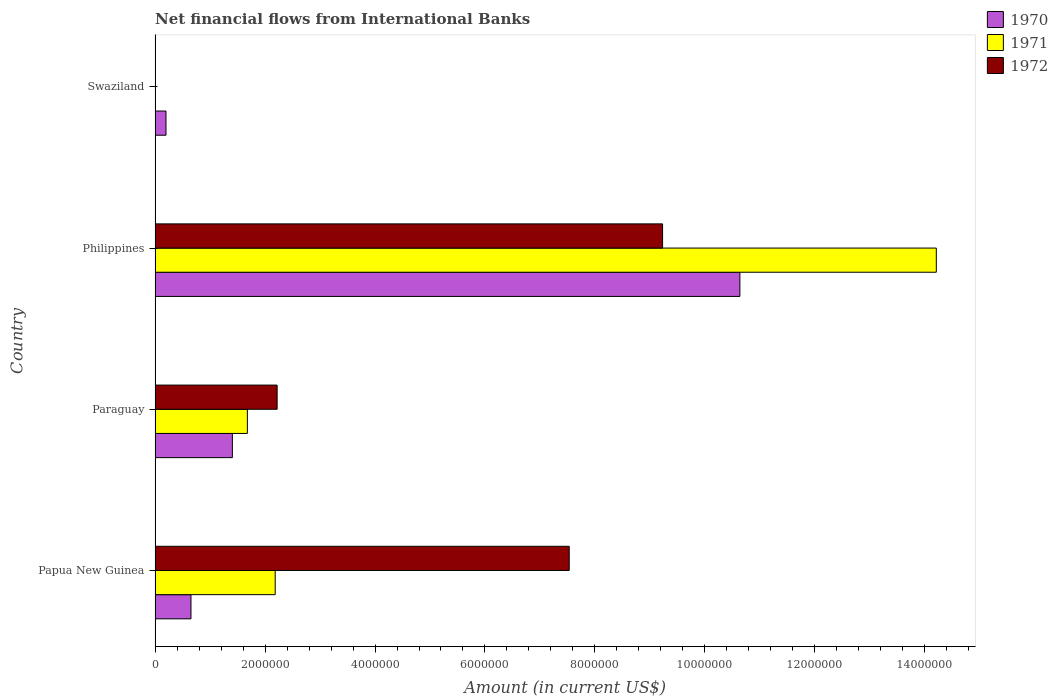How many different coloured bars are there?
Give a very brief answer. 3. Are the number of bars per tick equal to the number of legend labels?
Your response must be concise. No. Are the number of bars on each tick of the Y-axis equal?
Provide a succinct answer. No. How many bars are there on the 4th tick from the bottom?
Your answer should be compact. 1. What is the label of the 3rd group of bars from the top?
Ensure brevity in your answer.  Paraguay. In how many cases, is the number of bars for a given country not equal to the number of legend labels?
Your response must be concise. 1. What is the net financial aid flows in 1972 in Philippines?
Give a very brief answer. 9.23e+06. Across all countries, what is the maximum net financial aid flows in 1972?
Offer a terse response. 9.23e+06. Across all countries, what is the minimum net financial aid flows in 1972?
Provide a short and direct response. 0. In which country was the net financial aid flows in 1971 maximum?
Your answer should be compact. Philippines. What is the total net financial aid flows in 1971 in the graph?
Your response must be concise. 1.81e+07. What is the difference between the net financial aid flows in 1970 in Papua New Guinea and that in Paraguay?
Your answer should be very brief. -7.53e+05. What is the difference between the net financial aid flows in 1972 in Papua New Guinea and the net financial aid flows in 1970 in Swaziland?
Your answer should be compact. 7.33e+06. What is the average net financial aid flows in 1970 per country?
Your answer should be very brief. 3.22e+06. What is the difference between the net financial aid flows in 1972 and net financial aid flows in 1971 in Philippines?
Provide a short and direct response. -4.98e+06. In how many countries, is the net financial aid flows in 1972 greater than 5600000 US$?
Provide a short and direct response. 2. What is the ratio of the net financial aid flows in 1972 in Papua New Guinea to that in Philippines?
Ensure brevity in your answer.  0.82. What is the difference between the highest and the second highest net financial aid flows in 1972?
Offer a very short reply. 1.70e+06. What is the difference between the highest and the lowest net financial aid flows in 1972?
Provide a short and direct response. 9.23e+06. In how many countries, is the net financial aid flows in 1970 greater than the average net financial aid flows in 1970 taken over all countries?
Give a very brief answer. 1. Is it the case that in every country, the sum of the net financial aid flows in 1972 and net financial aid flows in 1970 is greater than the net financial aid flows in 1971?
Ensure brevity in your answer.  Yes. How many bars are there?
Keep it short and to the point. 10. Are the values on the major ticks of X-axis written in scientific E-notation?
Ensure brevity in your answer.  No. Does the graph contain grids?
Provide a short and direct response. No. How are the legend labels stacked?
Provide a short and direct response. Vertical. What is the title of the graph?
Give a very brief answer. Net financial flows from International Banks. What is the label or title of the Y-axis?
Make the answer very short. Country. What is the Amount (in current US$) of 1970 in Papua New Guinea?
Your response must be concise. 6.53e+05. What is the Amount (in current US$) of 1971 in Papua New Guinea?
Your answer should be compact. 2.18e+06. What is the Amount (in current US$) in 1972 in Papua New Guinea?
Provide a short and direct response. 7.53e+06. What is the Amount (in current US$) in 1970 in Paraguay?
Your answer should be compact. 1.41e+06. What is the Amount (in current US$) of 1971 in Paraguay?
Provide a short and direct response. 1.68e+06. What is the Amount (in current US$) of 1972 in Paraguay?
Give a very brief answer. 2.22e+06. What is the Amount (in current US$) of 1970 in Philippines?
Give a very brief answer. 1.06e+07. What is the Amount (in current US$) in 1971 in Philippines?
Offer a very short reply. 1.42e+07. What is the Amount (in current US$) of 1972 in Philippines?
Offer a very short reply. 9.23e+06. What is the Amount (in current US$) of 1970 in Swaziland?
Your answer should be compact. 1.99e+05. Across all countries, what is the maximum Amount (in current US$) of 1970?
Offer a terse response. 1.06e+07. Across all countries, what is the maximum Amount (in current US$) of 1971?
Offer a very short reply. 1.42e+07. Across all countries, what is the maximum Amount (in current US$) of 1972?
Ensure brevity in your answer.  9.23e+06. Across all countries, what is the minimum Amount (in current US$) of 1970?
Ensure brevity in your answer.  1.99e+05. Across all countries, what is the minimum Amount (in current US$) in 1971?
Keep it short and to the point. 0. What is the total Amount (in current US$) of 1970 in the graph?
Your response must be concise. 1.29e+07. What is the total Amount (in current US$) in 1971 in the graph?
Your answer should be very brief. 1.81e+07. What is the total Amount (in current US$) in 1972 in the graph?
Your response must be concise. 1.90e+07. What is the difference between the Amount (in current US$) of 1970 in Papua New Guinea and that in Paraguay?
Offer a very short reply. -7.53e+05. What is the difference between the Amount (in current US$) in 1971 in Papua New Guinea and that in Paraguay?
Your answer should be compact. 5.06e+05. What is the difference between the Amount (in current US$) of 1972 in Papua New Guinea and that in Paraguay?
Give a very brief answer. 5.31e+06. What is the difference between the Amount (in current US$) of 1970 in Papua New Guinea and that in Philippines?
Offer a very short reply. -9.98e+06. What is the difference between the Amount (in current US$) of 1971 in Papua New Guinea and that in Philippines?
Your answer should be compact. -1.20e+07. What is the difference between the Amount (in current US$) in 1972 in Papua New Guinea and that in Philippines?
Ensure brevity in your answer.  -1.70e+06. What is the difference between the Amount (in current US$) of 1970 in Papua New Guinea and that in Swaziland?
Provide a succinct answer. 4.54e+05. What is the difference between the Amount (in current US$) in 1970 in Paraguay and that in Philippines?
Your response must be concise. -9.23e+06. What is the difference between the Amount (in current US$) of 1971 in Paraguay and that in Philippines?
Provide a succinct answer. -1.25e+07. What is the difference between the Amount (in current US$) of 1972 in Paraguay and that in Philippines?
Your answer should be compact. -7.01e+06. What is the difference between the Amount (in current US$) in 1970 in Paraguay and that in Swaziland?
Ensure brevity in your answer.  1.21e+06. What is the difference between the Amount (in current US$) in 1970 in Philippines and that in Swaziland?
Provide a short and direct response. 1.04e+07. What is the difference between the Amount (in current US$) in 1970 in Papua New Guinea and the Amount (in current US$) in 1971 in Paraguay?
Your answer should be very brief. -1.03e+06. What is the difference between the Amount (in current US$) of 1970 in Papua New Guinea and the Amount (in current US$) of 1972 in Paraguay?
Offer a terse response. -1.57e+06. What is the difference between the Amount (in current US$) of 1971 in Papua New Guinea and the Amount (in current US$) of 1972 in Paraguay?
Your answer should be very brief. -3.50e+04. What is the difference between the Amount (in current US$) in 1970 in Papua New Guinea and the Amount (in current US$) in 1971 in Philippines?
Your answer should be very brief. -1.36e+07. What is the difference between the Amount (in current US$) in 1970 in Papua New Guinea and the Amount (in current US$) in 1972 in Philippines?
Your response must be concise. -8.58e+06. What is the difference between the Amount (in current US$) in 1971 in Papua New Guinea and the Amount (in current US$) in 1972 in Philippines?
Ensure brevity in your answer.  -7.04e+06. What is the difference between the Amount (in current US$) in 1970 in Paraguay and the Amount (in current US$) in 1971 in Philippines?
Your response must be concise. -1.28e+07. What is the difference between the Amount (in current US$) of 1970 in Paraguay and the Amount (in current US$) of 1972 in Philippines?
Your response must be concise. -7.82e+06. What is the difference between the Amount (in current US$) in 1971 in Paraguay and the Amount (in current US$) in 1972 in Philippines?
Ensure brevity in your answer.  -7.55e+06. What is the average Amount (in current US$) of 1970 per country?
Provide a succinct answer. 3.22e+06. What is the average Amount (in current US$) of 1971 per country?
Your answer should be compact. 4.52e+06. What is the average Amount (in current US$) in 1972 per country?
Your response must be concise. 4.75e+06. What is the difference between the Amount (in current US$) in 1970 and Amount (in current US$) in 1971 in Papua New Guinea?
Offer a very short reply. -1.53e+06. What is the difference between the Amount (in current US$) in 1970 and Amount (in current US$) in 1972 in Papua New Guinea?
Give a very brief answer. -6.88e+06. What is the difference between the Amount (in current US$) in 1971 and Amount (in current US$) in 1972 in Papua New Guinea?
Ensure brevity in your answer.  -5.35e+06. What is the difference between the Amount (in current US$) of 1970 and Amount (in current US$) of 1971 in Paraguay?
Provide a succinct answer. -2.73e+05. What is the difference between the Amount (in current US$) in 1970 and Amount (in current US$) in 1972 in Paraguay?
Give a very brief answer. -8.14e+05. What is the difference between the Amount (in current US$) in 1971 and Amount (in current US$) in 1972 in Paraguay?
Provide a succinct answer. -5.41e+05. What is the difference between the Amount (in current US$) in 1970 and Amount (in current US$) in 1971 in Philippines?
Provide a succinct answer. -3.57e+06. What is the difference between the Amount (in current US$) of 1970 and Amount (in current US$) of 1972 in Philippines?
Ensure brevity in your answer.  1.41e+06. What is the difference between the Amount (in current US$) in 1971 and Amount (in current US$) in 1972 in Philippines?
Your answer should be compact. 4.98e+06. What is the ratio of the Amount (in current US$) in 1970 in Papua New Guinea to that in Paraguay?
Your response must be concise. 0.46. What is the ratio of the Amount (in current US$) in 1971 in Papua New Guinea to that in Paraguay?
Make the answer very short. 1.3. What is the ratio of the Amount (in current US$) of 1972 in Papua New Guinea to that in Paraguay?
Make the answer very short. 3.39. What is the ratio of the Amount (in current US$) of 1970 in Papua New Guinea to that in Philippines?
Offer a terse response. 0.06. What is the ratio of the Amount (in current US$) in 1971 in Papua New Guinea to that in Philippines?
Offer a very short reply. 0.15. What is the ratio of the Amount (in current US$) in 1972 in Papua New Guinea to that in Philippines?
Offer a terse response. 0.82. What is the ratio of the Amount (in current US$) in 1970 in Papua New Guinea to that in Swaziland?
Give a very brief answer. 3.28. What is the ratio of the Amount (in current US$) of 1970 in Paraguay to that in Philippines?
Your answer should be very brief. 0.13. What is the ratio of the Amount (in current US$) of 1971 in Paraguay to that in Philippines?
Your answer should be compact. 0.12. What is the ratio of the Amount (in current US$) in 1972 in Paraguay to that in Philippines?
Your response must be concise. 0.24. What is the ratio of the Amount (in current US$) in 1970 in Paraguay to that in Swaziland?
Your response must be concise. 7.07. What is the ratio of the Amount (in current US$) in 1970 in Philippines to that in Swaziland?
Give a very brief answer. 53.45. What is the difference between the highest and the second highest Amount (in current US$) of 1970?
Provide a succinct answer. 9.23e+06. What is the difference between the highest and the second highest Amount (in current US$) of 1971?
Your response must be concise. 1.20e+07. What is the difference between the highest and the second highest Amount (in current US$) in 1972?
Give a very brief answer. 1.70e+06. What is the difference between the highest and the lowest Amount (in current US$) in 1970?
Keep it short and to the point. 1.04e+07. What is the difference between the highest and the lowest Amount (in current US$) of 1971?
Offer a terse response. 1.42e+07. What is the difference between the highest and the lowest Amount (in current US$) of 1972?
Provide a short and direct response. 9.23e+06. 